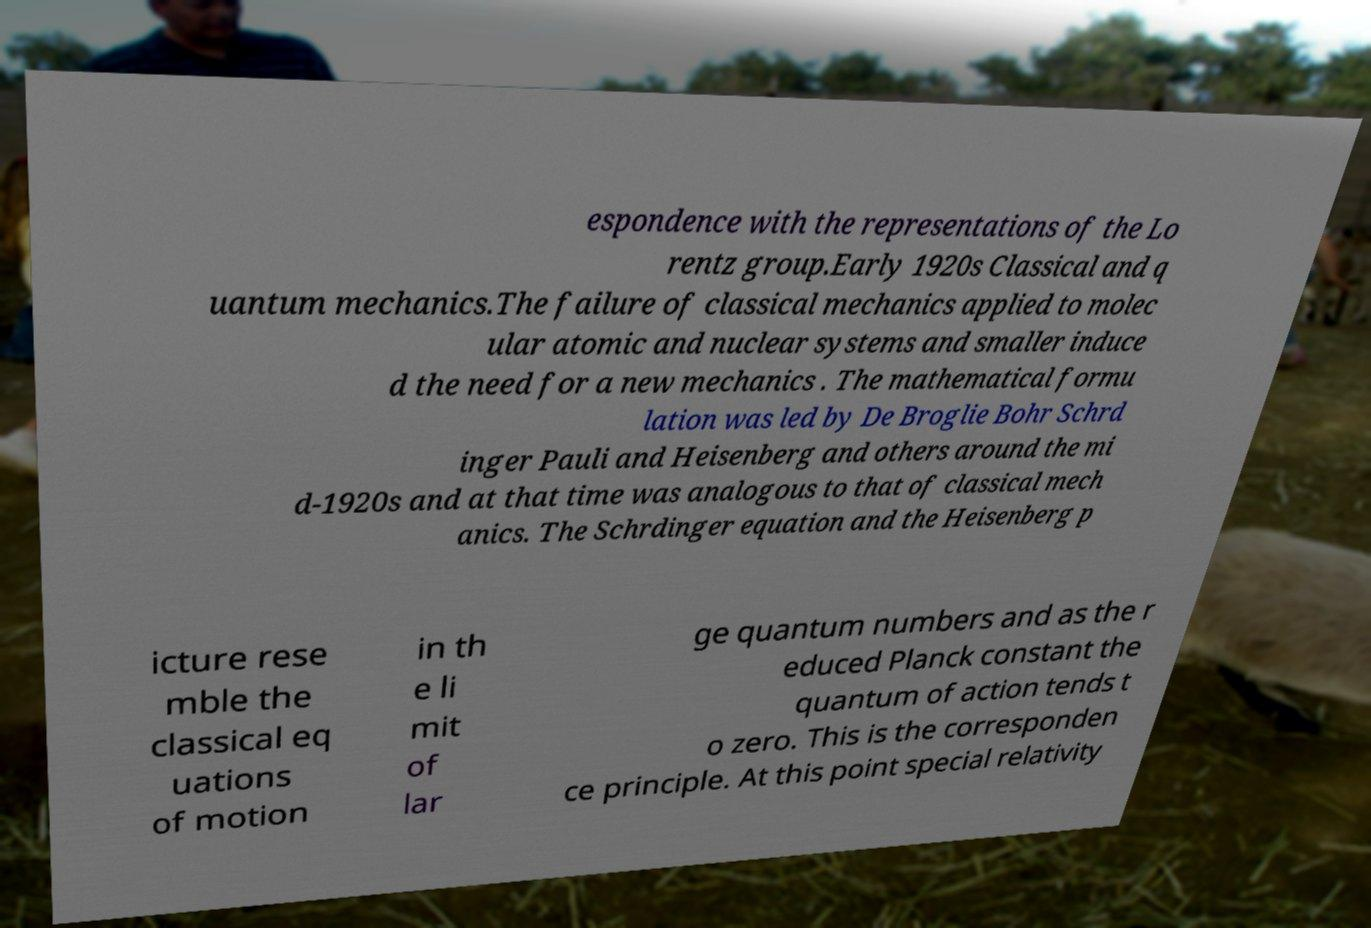Please identify and transcribe the text found in this image. espondence with the representations of the Lo rentz group.Early 1920s Classical and q uantum mechanics.The failure of classical mechanics applied to molec ular atomic and nuclear systems and smaller induce d the need for a new mechanics . The mathematical formu lation was led by De Broglie Bohr Schrd inger Pauli and Heisenberg and others around the mi d-1920s and at that time was analogous to that of classical mech anics. The Schrdinger equation and the Heisenberg p icture rese mble the classical eq uations of motion in th e li mit of lar ge quantum numbers and as the r educed Planck constant the quantum of action tends t o zero. This is the corresponden ce principle. At this point special relativity 